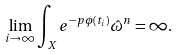<formula> <loc_0><loc_0><loc_500><loc_500>\lim _ { i \to \infty } \int _ { X } e ^ { - p \phi ( t _ { i } ) } \hat { \omega } ^ { n } = \infty .</formula> 